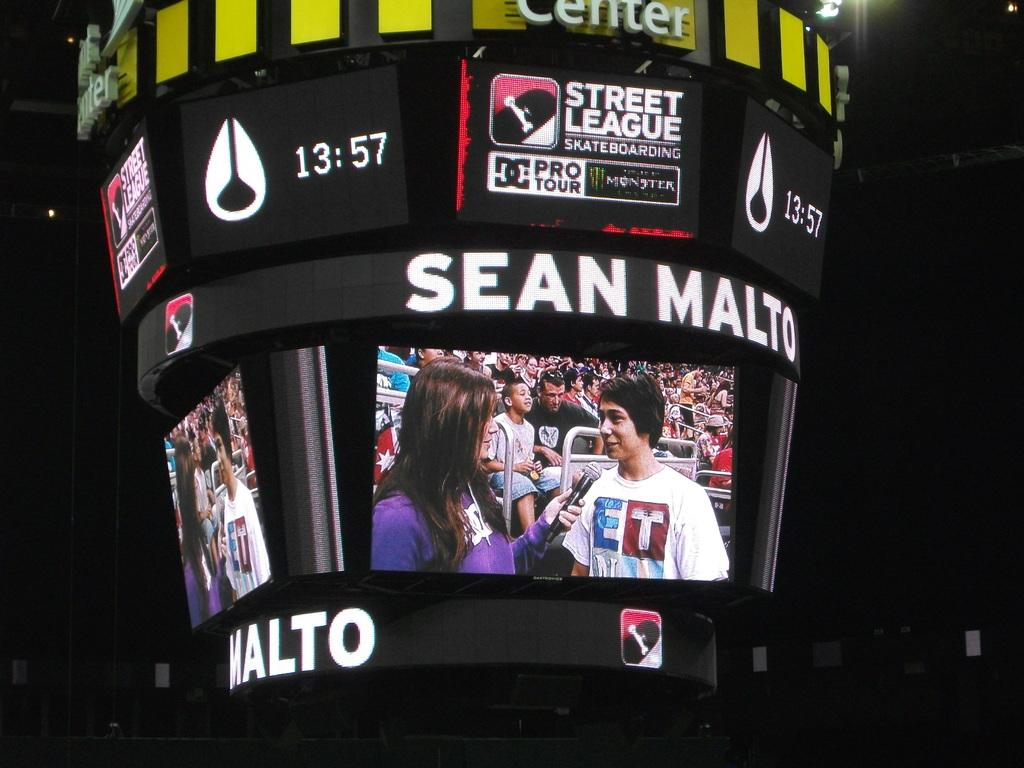<image>
Describe the image concisely. Scoreboard showing a sports announcer interviewing someone with the name Sean Malto. 